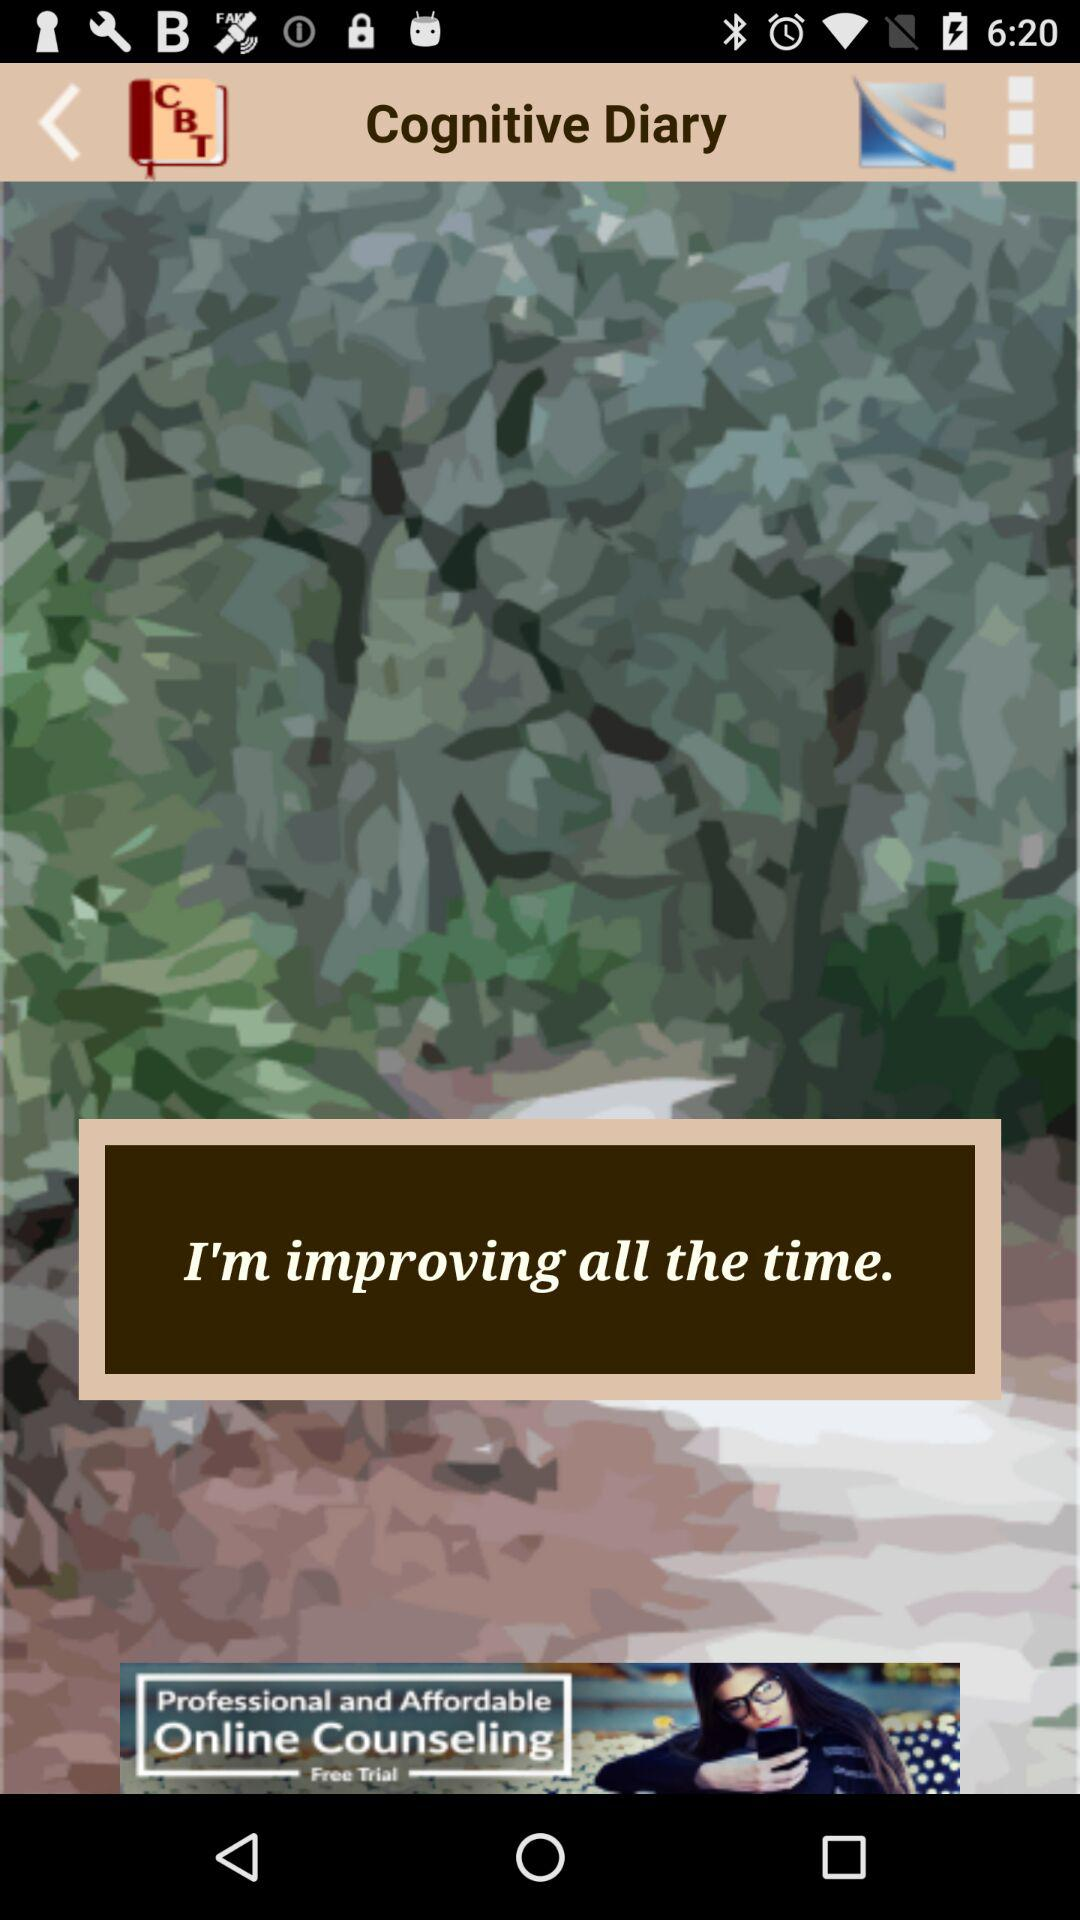How many entries are there?
When the provided information is insufficient, respond with <no answer>. <no answer> 